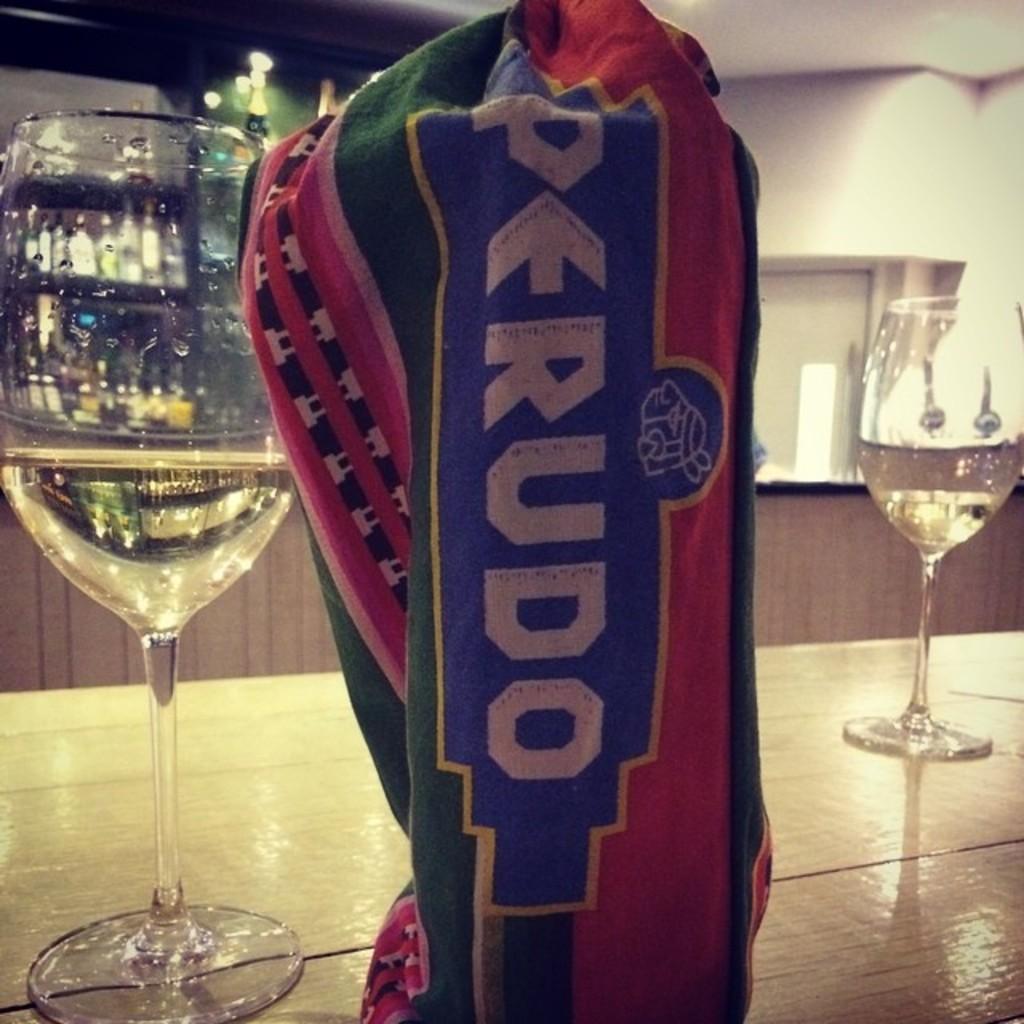What brand of drink is this?
Provide a succinct answer. Perudo. 